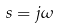<formula> <loc_0><loc_0><loc_500><loc_500>s = j \omega</formula> 